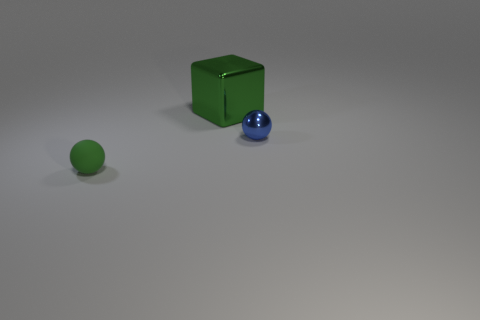Can you describe the spatial arrangement of the objects? Certainly, the green cube is centrally positioned, with the smaller green sphere off to its left, and the blue sphere to the right. The placement of the objects creates a triangular formation that adds balance and interest to the composition. 